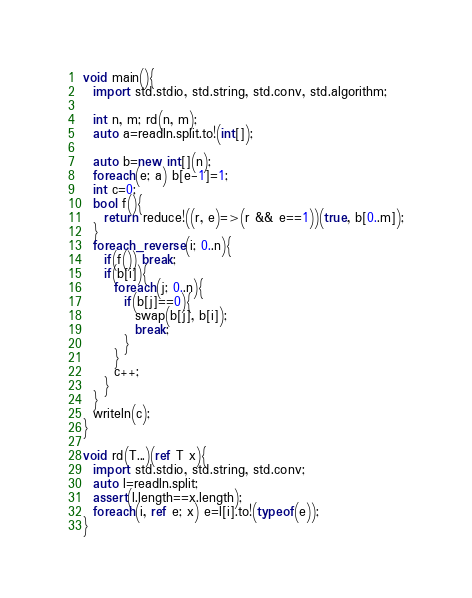<code> <loc_0><loc_0><loc_500><loc_500><_D_>void main(){
  import std.stdio, std.string, std.conv, std.algorithm;

  int n, m; rd(n, m);
  auto a=readln.split.to!(int[]);

  auto b=new int[](n);
  foreach(e; a) b[e-1]=1;
  int c=0;
  bool f(){
    return reduce!((r, e)=>(r && e==1))(true, b[0..m]);
  }
  foreach_reverse(i; 0..n){
    if(f()) break;
    if(b[i]){
      foreach(j; 0..n){
        if(b[j]==0){
          swap(b[j], b[i]);
          break;
        }
      }
      c++;
    }
  }
  writeln(c);
}

void rd(T...)(ref T x){
  import std.stdio, std.string, std.conv;
  auto l=readln.split;
  assert(l.length==x.length);
  foreach(i, ref e; x) e=l[i].to!(typeof(e));
}

</code> 